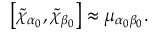Convert formula to latex. <formula><loc_0><loc_0><loc_500><loc_500>\left [ \tilde { \chi } _ { \alpha _ { 0 } } , \tilde { \chi } _ { \beta _ { 0 } } \right ] \approx \mu _ { \alpha _ { 0 } \beta _ { 0 } } .</formula> 